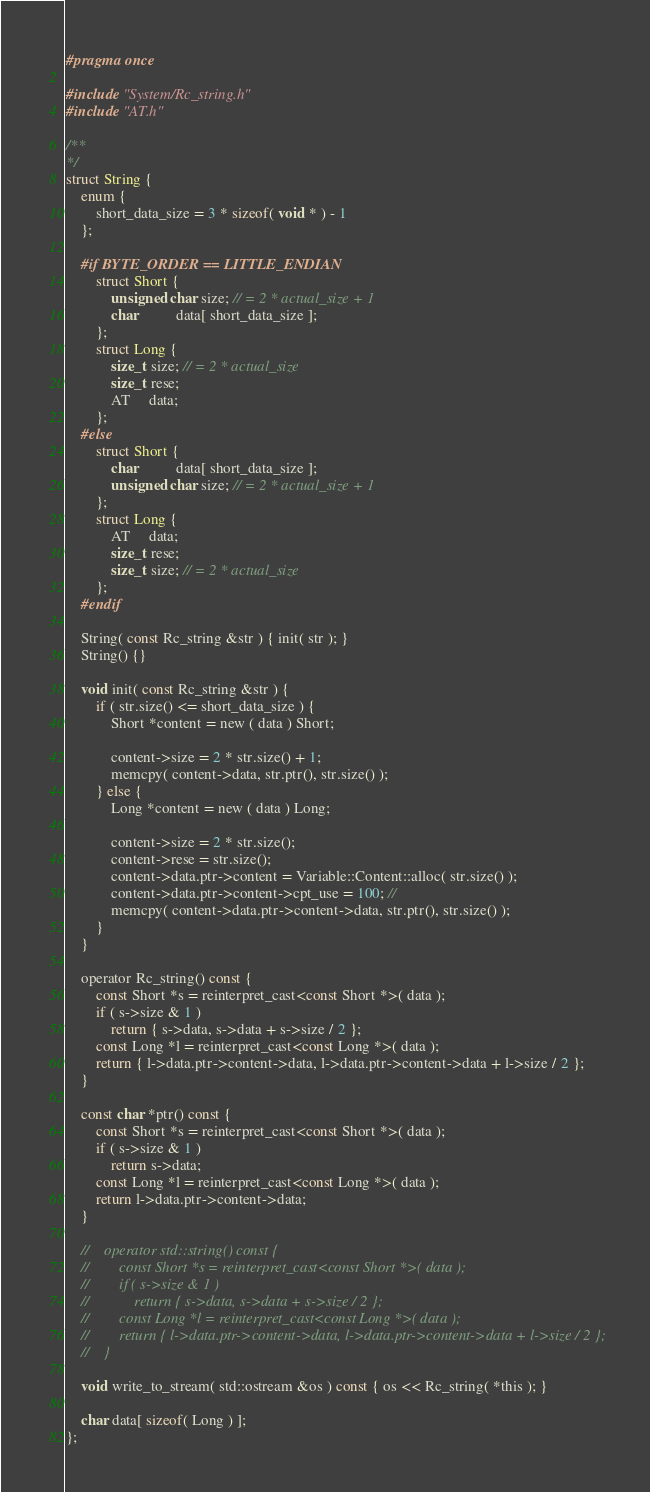Convert code to text. <code><loc_0><loc_0><loc_500><loc_500><_C_>#pragma once

#include "System/Rc_string.h"
#include "AT.h"

/**
*/
struct String {
    enum {
        short_data_size = 3 * sizeof( void * ) - 1
    };

    #if BYTE_ORDER == LITTLE_ENDIAN
        struct Short {
            unsigned char size; // = 2 * actual_size + 1
            char          data[ short_data_size ];
        };
        struct Long {
            size_t size; // = 2 * actual_size
            size_t rese;
            AT     data;
        };
    #else
        struct Short {
            char          data[ short_data_size ];
            unsigned char size; // = 2 * actual_size + 1
        };
        struct Long {
            AT     data;
            size_t rese;
            size_t size; // = 2 * actual_size
        };
    #endif

    String( const Rc_string &str ) { init( str ); }
    String() {}

    void init( const Rc_string &str ) {
        if ( str.size() <= short_data_size ) {
            Short *content = new ( data ) Short;

            content->size = 2 * str.size() + 1;
            memcpy( content->data, str.ptr(), str.size() );
        } else {
            Long *content = new ( data ) Long;

            content->size = 2 * str.size();
            content->rese = str.size();
            content->data.ptr->content = Variable::Content::alloc( str.size() );
            content->data.ptr->content->cpt_use = 100; //
            memcpy( content->data.ptr->content->data, str.ptr(), str.size() );
        }
    }

    operator Rc_string() const {
        const Short *s = reinterpret_cast<const Short *>( data );
        if ( s->size & 1 )
            return { s->data, s->data + s->size / 2 };
        const Long *l = reinterpret_cast<const Long *>( data );
        return { l->data.ptr->content->data, l->data.ptr->content->data + l->size / 2 };
    }

    const char *ptr() const {
        const Short *s = reinterpret_cast<const Short *>( data );
        if ( s->size & 1 )
            return s->data;
        const Long *l = reinterpret_cast<const Long *>( data );
        return l->data.ptr->content->data;
    }

    //    operator std::string() const {
    //        const Short *s = reinterpret_cast<const Short *>( data );
    //        if ( s->size & 1 )
    //            return { s->data, s->data + s->size / 2 };
    //        const Long *l = reinterpret_cast<const Long *>( data );
    //        return { l->data.ptr->content->data, l->data.ptr->content->data + l->size / 2 };
    //    }

    void write_to_stream( std::ostream &os ) const { os << Rc_string( *this ); }

    char data[ sizeof( Long ) ];
};
</code> 